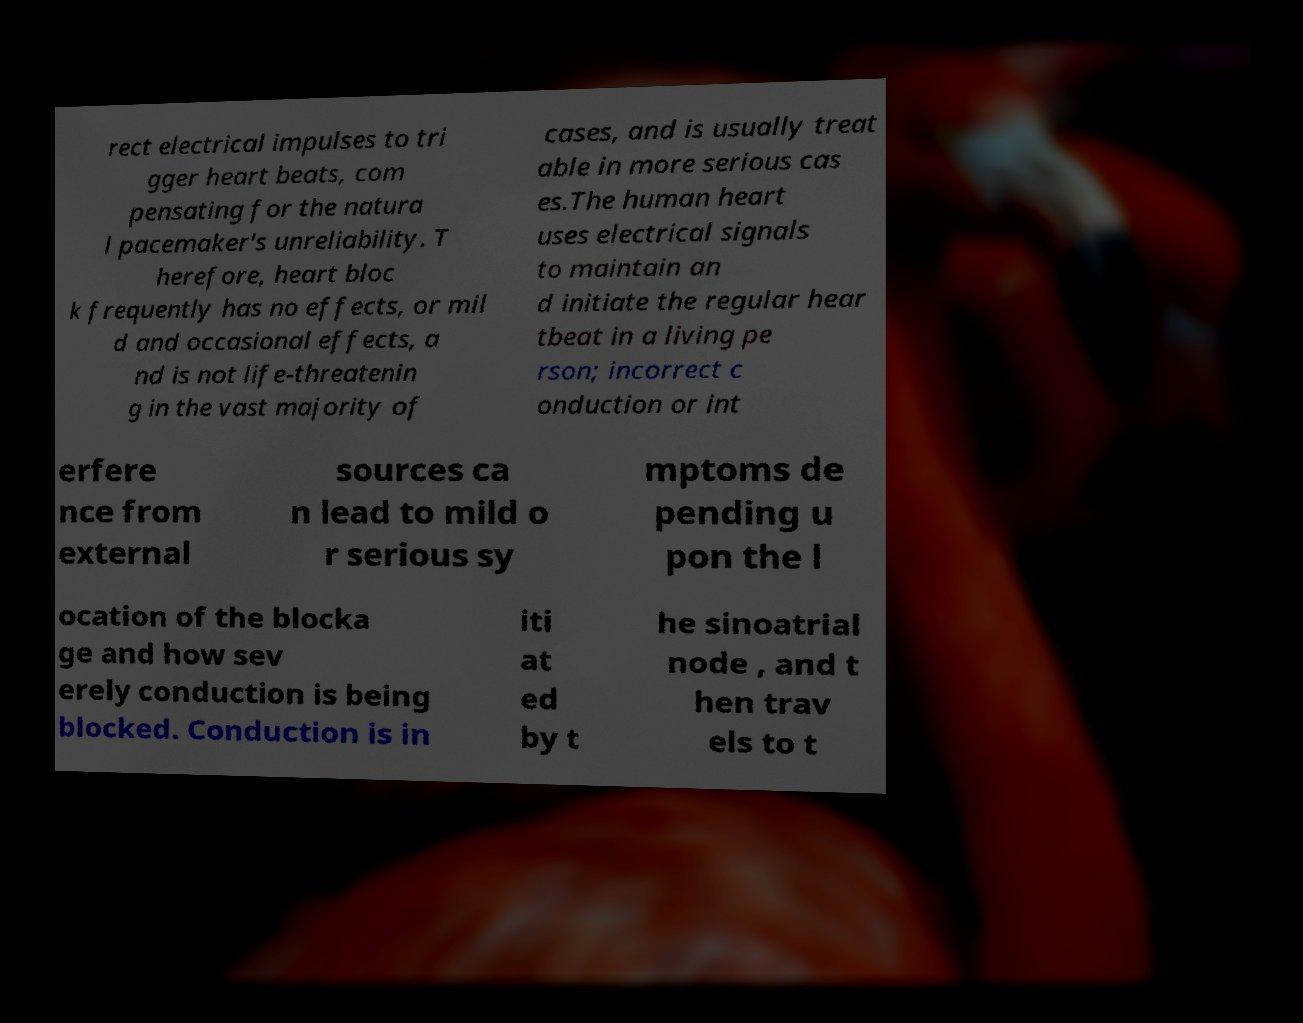Could you extract and type out the text from this image? rect electrical impulses to tri gger heart beats, com pensating for the natura l pacemaker's unreliability. T herefore, heart bloc k frequently has no effects, or mil d and occasional effects, a nd is not life-threatenin g in the vast majority of cases, and is usually treat able in more serious cas es.The human heart uses electrical signals to maintain an d initiate the regular hear tbeat in a living pe rson; incorrect c onduction or int erfere nce from external sources ca n lead to mild o r serious sy mptoms de pending u pon the l ocation of the blocka ge and how sev erely conduction is being blocked. Conduction is in iti at ed by t he sinoatrial node , and t hen trav els to t 